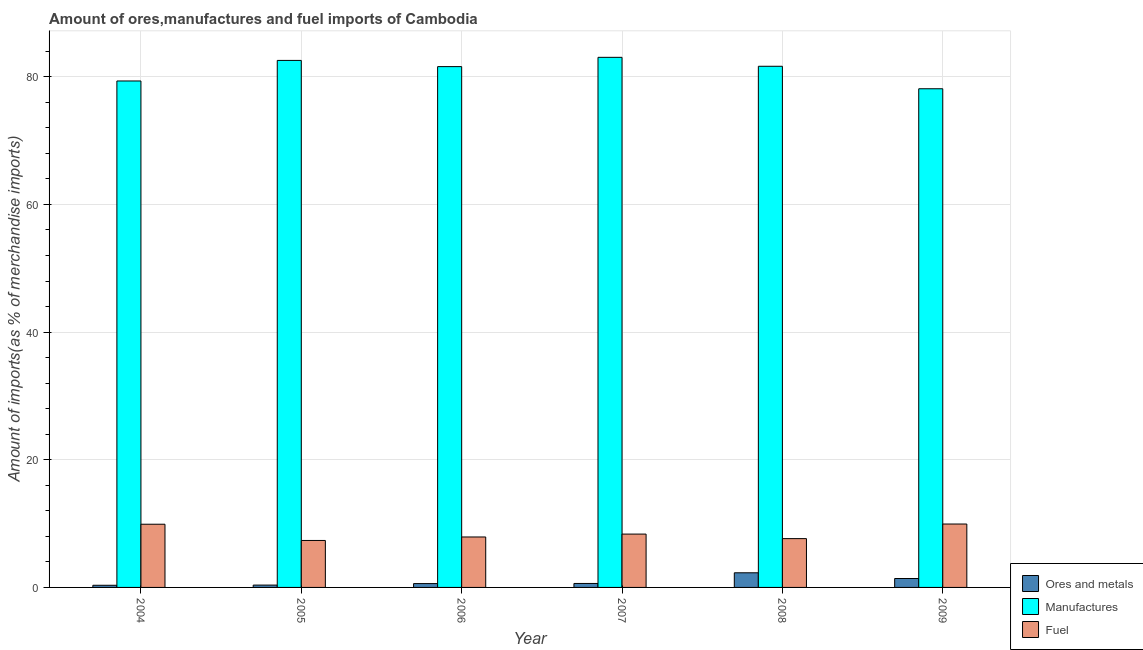How many different coloured bars are there?
Offer a very short reply. 3. How many groups of bars are there?
Make the answer very short. 6. Are the number of bars on each tick of the X-axis equal?
Provide a short and direct response. Yes. How many bars are there on the 2nd tick from the left?
Provide a succinct answer. 3. What is the percentage of ores and metals imports in 2008?
Ensure brevity in your answer.  2.29. Across all years, what is the maximum percentage of manufactures imports?
Offer a terse response. 83.05. Across all years, what is the minimum percentage of ores and metals imports?
Make the answer very short. 0.34. In which year was the percentage of manufactures imports maximum?
Make the answer very short. 2007. In which year was the percentage of manufactures imports minimum?
Offer a very short reply. 2009. What is the total percentage of fuel imports in the graph?
Keep it short and to the point. 51.1. What is the difference between the percentage of manufactures imports in 2004 and that in 2005?
Keep it short and to the point. -3.22. What is the difference between the percentage of fuel imports in 2007 and the percentage of ores and metals imports in 2008?
Your answer should be compact. 0.71. What is the average percentage of fuel imports per year?
Give a very brief answer. 8.52. In the year 2004, what is the difference between the percentage of ores and metals imports and percentage of manufactures imports?
Provide a succinct answer. 0. What is the ratio of the percentage of manufactures imports in 2004 to that in 2009?
Provide a short and direct response. 1.02. Is the difference between the percentage of fuel imports in 2004 and 2008 greater than the difference between the percentage of ores and metals imports in 2004 and 2008?
Your response must be concise. No. What is the difference between the highest and the second highest percentage of fuel imports?
Provide a succinct answer. 0.03. What is the difference between the highest and the lowest percentage of ores and metals imports?
Your answer should be compact. 1.96. In how many years, is the percentage of manufactures imports greater than the average percentage of manufactures imports taken over all years?
Your answer should be compact. 4. What does the 1st bar from the left in 2004 represents?
Your answer should be very brief. Ores and metals. What does the 1st bar from the right in 2007 represents?
Give a very brief answer. Fuel. Is it the case that in every year, the sum of the percentage of ores and metals imports and percentage of manufactures imports is greater than the percentage of fuel imports?
Your response must be concise. Yes. Are all the bars in the graph horizontal?
Your response must be concise. No. Are the values on the major ticks of Y-axis written in scientific E-notation?
Your response must be concise. No. Does the graph contain any zero values?
Offer a very short reply. No. Does the graph contain grids?
Your answer should be compact. Yes. Where does the legend appear in the graph?
Offer a very short reply. Bottom right. How many legend labels are there?
Provide a short and direct response. 3. What is the title of the graph?
Provide a succinct answer. Amount of ores,manufactures and fuel imports of Cambodia. Does "Agriculture" appear as one of the legend labels in the graph?
Provide a succinct answer. No. What is the label or title of the Y-axis?
Keep it short and to the point. Amount of imports(as % of merchandise imports). What is the Amount of imports(as % of merchandise imports) in Ores and metals in 2004?
Offer a very short reply. 0.34. What is the Amount of imports(as % of merchandise imports) in Manufactures in 2004?
Keep it short and to the point. 79.35. What is the Amount of imports(as % of merchandise imports) of Fuel in 2004?
Keep it short and to the point. 9.9. What is the Amount of imports(as % of merchandise imports) of Ores and metals in 2005?
Keep it short and to the point. 0.37. What is the Amount of imports(as % of merchandise imports) of Manufactures in 2005?
Ensure brevity in your answer.  82.57. What is the Amount of imports(as % of merchandise imports) in Fuel in 2005?
Offer a very short reply. 7.36. What is the Amount of imports(as % of merchandise imports) of Ores and metals in 2006?
Offer a terse response. 0.6. What is the Amount of imports(as % of merchandise imports) in Manufactures in 2006?
Your response must be concise. 81.6. What is the Amount of imports(as % of merchandise imports) in Fuel in 2006?
Ensure brevity in your answer.  7.9. What is the Amount of imports(as % of merchandise imports) in Ores and metals in 2007?
Your answer should be very brief. 0.62. What is the Amount of imports(as % of merchandise imports) of Manufactures in 2007?
Provide a succinct answer. 83.05. What is the Amount of imports(as % of merchandise imports) of Fuel in 2007?
Provide a short and direct response. 8.36. What is the Amount of imports(as % of merchandise imports) in Ores and metals in 2008?
Your answer should be compact. 2.29. What is the Amount of imports(as % of merchandise imports) in Manufactures in 2008?
Provide a short and direct response. 81.65. What is the Amount of imports(as % of merchandise imports) in Fuel in 2008?
Keep it short and to the point. 7.65. What is the Amount of imports(as % of merchandise imports) of Ores and metals in 2009?
Keep it short and to the point. 1.4. What is the Amount of imports(as % of merchandise imports) of Manufactures in 2009?
Offer a very short reply. 78.13. What is the Amount of imports(as % of merchandise imports) of Fuel in 2009?
Offer a very short reply. 9.93. Across all years, what is the maximum Amount of imports(as % of merchandise imports) of Ores and metals?
Your answer should be very brief. 2.29. Across all years, what is the maximum Amount of imports(as % of merchandise imports) of Manufactures?
Your response must be concise. 83.05. Across all years, what is the maximum Amount of imports(as % of merchandise imports) of Fuel?
Keep it short and to the point. 9.93. Across all years, what is the minimum Amount of imports(as % of merchandise imports) in Ores and metals?
Offer a very short reply. 0.34. Across all years, what is the minimum Amount of imports(as % of merchandise imports) of Manufactures?
Your answer should be compact. 78.13. Across all years, what is the minimum Amount of imports(as % of merchandise imports) of Fuel?
Your answer should be very brief. 7.36. What is the total Amount of imports(as % of merchandise imports) of Ores and metals in the graph?
Give a very brief answer. 5.61. What is the total Amount of imports(as % of merchandise imports) of Manufactures in the graph?
Make the answer very short. 486.33. What is the total Amount of imports(as % of merchandise imports) in Fuel in the graph?
Give a very brief answer. 51.1. What is the difference between the Amount of imports(as % of merchandise imports) in Ores and metals in 2004 and that in 2005?
Your response must be concise. -0.03. What is the difference between the Amount of imports(as % of merchandise imports) of Manufactures in 2004 and that in 2005?
Give a very brief answer. -3.22. What is the difference between the Amount of imports(as % of merchandise imports) in Fuel in 2004 and that in 2005?
Offer a very short reply. 2.54. What is the difference between the Amount of imports(as % of merchandise imports) in Ores and metals in 2004 and that in 2006?
Ensure brevity in your answer.  -0.26. What is the difference between the Amount of imports(as % of merchandise imports) in Manufactures in 2004 and that in 2006?
Your response must be concise. -2.25. What is the difference between the Amount of imports(as % of merchandise imports) in Fuel in 2004 and that in 2006?
Offer a very short reply. 2. What is the difference between the Amount of imports(as % of merchandise imports) in Ores and metals in 2004 and that in 2007?
Your answer should be compact. -0.28. What is the difference between the Amount of imports(as % of merchandise imports) of Manufactures in 2004 and that in 2007?
Offer a terse response. -3.7. What is the difference between the Amount of imports(as % of merchandise imports) in Fuel in 2004 and that in 2007?
Offer a terse response. 1.54. What is the difference between the Amount of imports(as % of merchandise imports) in Ores and metals in 2004 and that in 2008?
Make the answer very short. -1.96. What is the difference between the Amount of imports(as % of merchandise imports) of Manufactures in 2004 and that in 2008?
Ensure brevity in your answer.  -2.3. What is the difference between the Amount of imports(as % of merchandise imports) of Fuel in 2004 and that in 2008?
Your answer should be very brief. 2.25. What is the difference between the Amount of imports(as % of merchandise imports) in Ores and metals in 2004 and that in 2009?
Provide a succinct answer. -1.06. What is the difference between the Amount of imports(as % of merchandise imports) of Manufactures in 2004 and that in 2009?
Offer a terse response. 1.22. What is the difference between the Amount of imports(as % of merchandise imports) in Fuel in 2004 and that in 2009?
Provide a short and direct response. -0.03. What is the difference between the Amount of imports(as % of merchandise imports) of Ores and metals in 2005 and that in 2006?
Give a very brief answer. -0.24. What is the difference between the Amount of imports(as % of merchandise imports) in Manufactures in 2005 and that in 2006?
Provide a short and direct response. 0.97. What is the difference between the Amount of imports(as % of merchandise imports) of Fuel in 2005 and that in 2006?
Your answer should be compact. -0.55. What is the difference between the Amount of imports(as % of merchandise imports) in Ores and metals in 2005 and that in 2007?
Ensure brevity in your answer.  -0.25. What is the difference between the Amount of imports(as % of merchandise imports) in Manufactures in 2005 and that in 2007?
Ensure brevity in your answer.  -0.48. What is the difference between the Amount of imports(as % of merchandise imports) in Fuel in 2005 and that in 2007?
Your answer should be compact. -1. What is the difference between the Amount of imports(as % of merchandise imports) of Ores and metals in 2005 and that in 2008?
Your answer should be compact. -1.93. What is the difference between the Amount of imports(as % of merchandise imports) of Manufactures in 2005 and that in 2008?
Keep it short and to the point. 0.92. What is the difference between the Amount of imports(as % of merchandise imports) in Fuel in 2005 and that in 2008?
Make the answer very short. -0.29. What is the difference between the Amount of imports(as % of merchandise imports) of Ores and metals in 2005 and that in 2009?
Your answer should be compact. -1.03. What is the difference between the Amount of imports(as % of merchandise imports) of Manufactures in 2005 and that in 2009?
Provide a succinct answer. 4.44. What is the difference between the Amount of imports(as % of merchandise imports) of Fuel in 2005 and that in 2009?
Give a very brief answer. -2.57. What is the difference between the Amount of imports(as % of merchandise imports) of Ores and metals in 2006 and that in 2007?
Offer a very short reply. -0.02. What is the difference between the Amount of imports(as % of merchandise imports) of Manufactures in 2006 and that in 2007?
Provide a succinct answer. -1.46. What is the difference between the Amount of imports(as % of merchandise imports) in Fuel in 2006 and that in 2007?
Make the answer very short. -0.45. What is the difference between the Amount of imports(as % of merchandise imports) of Ores and metals in 2006 and that in 2008?
Provide a short and direct response. -1.69. What is the difference between the Amount of imports(as % of merchandise imports) in Manufactures in 2006 and that in 2008?
Provide a succinct answer. -0.05. What is the difference between the Amount of imports(as % of merchandise imports) of Fuel in 2006 and that in 2008?
Provide a succinct answer. 0.26. What is the difference between the Amount of imports(as % of merchandise imports) of Ores and metals in 2006 and that in 2009?
Ensure brevity in your answer.  -0.8. What is the difference between the Amount of imports(as % of merchandise imports) of Manufactures in 2006 and that in 2009?
Offer a very short reply. 3.47. What is the difference between the Amount of imports(as % of merchandise imports) of Fuel in 2006 and that in 2009?
Keep it short and to the point. -2.03. What is the difference between the Amount of imports(as % of merchandise imports) of Ores and metals in 2007 and that in 2008?
Your answer should be very brief. -1.67. What is the difference between the Amount of imports(as % of merchandise imports) of Manufactures in 2007 and that in 2008?
Keep it short and to the point. 1.4. What is the difference between the Amount of imports(as % of merchandise imports) of Fuel in 2007 and that in 2008?
Your answer should be very brief. 0.71. What is the difference between the Amount of imports(as % of merchandise imports) in Ores and metals in 2007 and that in 2009?
Your response must be concise. -0.78. What is the difference between the Amount of imports(as % of merchandise imports) in Manufactures in 2007 and that in 2009?
Offer a very short reply. 4.92. What is the difference between the Amount of imports(as % of merchandise imports) of Fuel in 2007 and that in 2009?
Offer a terse response. -1.57. What is the difference between the Amount of imports(as % of merchandise imports) of Ores and metals in 2008 and that in 2009?
Give a very brief answer. 0.89. What is the difference between the Amount of imports(as % of merchandise imports) of Manufactures in 2008 and that in 2009?
Your response must be concise. 3.52. What is the difference between the Amount of imports(as % of merchandise imports) in Fuel in 2008 and that in 2009?
Make the answer very short. -2.29. What is the difference between the Amount of imports(as % of merchandise imports) of Ores and metals in 2004 and the Amount of imports(as % of merchandise imports) of Manufactures in 2005?
Your response must be concise. -82.23. What is the difference between the Amount of imports(as % of merchandise imports) in Ores and metals in 2004 and the Amount of imports(as % of merchandise imports) in Fuel in 2005?
Give a very brief answer. -7.02. What is the difference between the Amount of imports(as % of merchandise imports) of Manufactures in 2004 and the Amount of imports(as % of merchandise imports) of Fuel in 2005?
Offer a very short reply. 71.99. What is the difference between the Amount of imports(as % of merchandise imports) in Ores and metals in 2004 and the Amount of imports(as % of merchandise imports) in Manufactures in 2006?
Your response must be concise. -81.26. What is the difference between the Amount of imports(as % of merchandise imports) in Ores and metals in 2004 and the Amount of imports(as % of merchandise imports) in Fuel in 2006?
Your answer should be compact. -7.57. What is the difference between the Amount of imports(as % of merchandise imports) in Manufactures in 2004 and the Amount of imports(as % of merchandise imports) in Fuel in 2006?
Offer a very short reply. 71.44. What is the difference between the Amount of imports(as % of merchandise imports) of Ores and metals in 2004 and the Amount of imports(as % of merchandise imports) of Manufactures in 2007?
Give a very brief answer. -82.71. What is the difference between the Amount of imports(as % of merchandise imports) of Ores and metals in 2004 and the Amount of imports(as % of merchandise imports) of Fuel in 2007?
Make the answer very short. -8.02. What is the difference between the Amount of imports(as % of merchandise imports) in Manufactures in 2004 and the Amount of imports(as % of merchandise imports) in Fuel in 2007?
Provide a short and direct response. 70.99. What is the difference between the Amount of imports(as % of merchandise imports) of Ores and metals in 2004 and the Amount of imports(as % of merchandise imports) of Manufactures in 2008?
Provide a succinct answer. -81.31. What is the difference between the Amount of imports(as % of merchandise imports) of Ores and metals in 2004 and the Amount of imports(as % of merchandise imports) of Fuel in 2008?
Give a very brief answer. -7.31. What is the difference between the Amount of imports(as % of merchandise imports) in Manufactures in 2004 and the Amount of imports(as % of merchandise imports) in Fuel in 2008?
Ensure brevity in your answer.  71.7. What is the difference between the Amount of imports(as % of merchandise imports) in Ores and metals in 2004 and the Amount of imports(as % of merchandise imports) in Manufactures in 2009?
Keep it short and to the point. -77.79. What is the difference between the Amount of imports(as % of merchandise imports) in Ores and metals in 2004 and the Amount of imports(as % of merchandise imports) in Fuel in 2009?
Ensure brevity in your answer.  -9.6. What is the difference between the Amount of imports(as % of merchandise imports) in Manufactures in 2004 and the Amount of imports(as % of merchandise imports) in Fuel in 2009?
Give a very brief answer. 69.41. What is the difference between the Amount of imports(as % of merchandise imports) in Ores and metals in 2005 and the Amount of imports(as % of merchandise imports) in Manufactures in 2006?
Your response must be concise. -81.23. What is the difference between the Amount of imports(as % of merchandise imports) of Ores and metals in 2005 and the Amount of imports(as % of merchandise imports) of Fuel in 2006?
Give a very brief answer. -7.54. What is the difference between the Amount of imports(as % of merchandise imports) in Manufactures in 2005 and the Amount of imports(as % of merchandise imports) in Fuel in 2006?
Give a very brief answer. 74.66. What is the difference between the Amount of imports(as % of merchandise imports) in Ores and metals in 2005 and the Amount of imports(as % of merchandise imports) in Manufactures in 2007?
Provide a succinct answer. -82.68. What is the difference between the Amount of imports(as % of merchandise imports) of Ores and metals in 2005 and the Amount of imports(as % of merchandise imports) of Fuel in 2007?
Provide a succinct answer. -7.99. What is the difference between the Amount of imports(as % of merchandise imports) of Manufactures in 2005 and the Amount of imports(as % of merchandise imports) of Fuel in 2007?
Your answer should be compact. 74.21. What is the difference between the Amount of imports(as % of merchandise imports) of Ores and metals in 2005 and the Amount of imports(as % of merchandise imports) of Manufactures in 2008?
Your response must be concise. -81.28. What is the difference between the Amount of imports(as % of merchandise imports) in Ores and metals in 2005 and the Amount of imports(as % of merchandise imports) in Fuel in 2008?
Provide a short and direct response. -7.28. What is the difference between the Amount of imports(as % of merchandise imports) in Manufactures in 2005 and the Amount of imports(as % of merchandise imports) in Fuel in 2008?
Offer a very short reply. 74.92. What is the difference between the Amount of imports(as % of merchandise imports) in Ores and metals in 2005 and the Amount of imports(as % of merchandise imports) in Manufactures in 2009?
Ensure brevity in your answer.  -77.76. What is the difference between the Amount of imports(as % of merchandise imports) of Ores and metals in 2005 and the Amount of imports(as % of merchandise imports) of Fuel in 2009?
Make the answer very short. -9.57. What is the difference between the Amount of imports(as % of merchandise imports) of Manufactures in 2005 and the Amount of imports(as % of merchandise imports) of Fuel in 2009?
Your answer should be compact. 72.63. What is the difference between the Amount of imports(as % of merchandise imports) in Ores and metals in 2006 and the Amount of imports(as % of merchandise imports) in Manufactures in 2007?
Make the answer very short. -82.45. What is the difference between the Amount of imports(as % of merchandise imports) in Ores and metals in 2006 and the Amount of imports(as % of merchandise imports) in Fuel in 2007?
Give a very brief answer. -7.76. What is the difference between the Amount of imports(as % of merchandise imports) in Manufactures in 2006 and the Amount of imports(as % of merchandise imports) in Fuel in 2007?
Your response must be concise. 73.24. What is the difference between the Amount of imports(as % of merchandise imports) in Ores and metals in 2006 and the Amount of imports(as % of merchandise imports) in Manufactures in 2008?
Provide a succinct answer. -81.05. What is the difference between the Amount of imports(as % of merchandise imports) in Ores and metals in 2006 and the Amount of imports(as % of merchandise imports) in Fuel in 2008?
Your answer should be compact. -7.05. What is the difference between the Amount of imports(as % of merchandise imports) of Manufactures in 2006 and the Amount of imports(as % of merchandise imports) of Fuel in 2008?
Provide a succinct answer. 73.95. What is the difference between the Amount of imports(as % of merchandise imports) in Ores and metals in 2006 and the Amount of imports(as % of merchandise imports) in Manufactures in 2009?
Ensure brevity in your answer.  -77.52. What is the difference between the Amount of imports(as % of merchandise imports) in Ores and metals in 2006 and the Amount of imports(as % of merchandise imports) in Fuel in 2009?
Provide a short and direct response. -9.33. What is the difference between the Amount of imports(as % of merchandise imports) in Manufactures in 2006 and the Amount of imports(as % of merchandise imports) in Fuel in 2009?
Provide a succinct answer. 71.66. What is the difference between the Amount of imports(as % of merchandise imports) in Ores and metals in 2007 and the Amount of imports(as % of merchandise imports) in Manufactures in 2008?
Provide a short and direct response. -81.03. What is the difference between the Amount of imports(as % of merchandise imports) of Ores and metals in 2007 and the Amount of imports(as % of merchandise imports) of Fuel in 2008?
Your answer should be compact. -7.03. What is the difference between the Amount of imports(as % of merchandise imports) of Manufactures in 2007 and the Amount of imports(as % of merchandise imports) of Fuel in 2008?
Provide a short and direct response. 75.4. What is the difference between the Amount of imports(as % of merchandise imports) in Ores and metals in 2007 and the Amount of imports(as % of merchandise imports) in Manufactures in 2009?
Make the answer very short. -77.51. What is the difference between the Amount of imports(as % of merchandise imports) in Ores and metals in 2007 and the Amount of imports(as % of merchandise imports) in Fuel in 2009?
Your answer should be very brief. -9.31. What is the difference between the Amount of imports(as % of merchandise imports) of Manufactures in 2007 and the Amount of imports(as % of merchandise imports) of Fuel in 2009?
Offer a very short reply. 73.12. What is the difference between the Amount of imports(as % of merchandise imports) of Ores and metals in 2008 and the Amount of imports(as % of merchandise imports) of Manufactures in 2009?
Provide a succinct answer. -75.83. What is the difference between the Amount of imports(as % of merchandise imports) of Ores and metals in 2008 and the Amount of imports(as % of merchandise imports) of Fuel in 2009?
Your answer should be very brief. -7.64. What is the difference between the Amount of imports(as % of merchandise imports) in Manufactures in 2008 and the Amount of imports(as % of merchandise imports) in Fuel in 2009?
Give a very brief answer. 71.72. What is the average Amount of imports(as % of merchandise imports) in Ores and metals per year?
Offer a terse response. 0.94. What is the average Amount of imports(as % of merchandise imports) in Manufactures per year?
Your response must be concise. 81.06. What is the average Amount of imports(as % of merchandise imports) of Fuel per year?
Offer a terse response. 8.52. In the year 2004, what is the difference between the Amount of imports(as % of merchandise imports) of Ores and metals and Amount of imports(as % of merchandise imports) of Manufactures?
Make the answer very short. -79.01. In the year 2004, what is the difference between the Amount of imports(as % of merchandise imports) of Ores and metals and Amount of imports(as % of merchandise imports) of Fuel?
Offer a terse response. -9.56. In the year 2004, what is the difference between the Amount of imports(as % of merchandise imports) of Manufactures and Amount of imports(as % of merchandise imports) of Fuel?
Give a very brief answer. 69.45. In the year 2005, what is the difference between the Amount of imports(as % of merchandise imports) of Ores and metals and Amount of imports(as % of merchandise imports) of Manufactures?
Offer a very short reply. -82.2. In the year 2005, what is the difference between the Amount of imports(as % of merchandise imports) of Ores and metals and Amount of imports(as % of merchandise imports) of Fuel?
Keep it short and to the point. -6.99. In the year 2005, what is the difference between the Amount of imports(as % of merchandise imports) in Manufactures and Amount of imports(as % of merchandise imports) in Fuel?
Your response must be concise. 75.21. In the year 2006, what is the difference between the Amount of imports(as % of merchandise imports) of Ores and metals and Amount of imports(as % of merchandise imports) of Manufactures?
Ensure brevity in your answer.  -80.99. In the year 2006, what is the difference between the Amount of imports(as % of merchandise imports) in Ores and metals and Amount of imports(as % of merchandise imports) in Fuel?
Offer a terse response. -7.3. In the year 2006, what is the difference between the Amount of imports(as % of merchandise imports) of Manufactures and Amount of imports(as % of merchandise imports) of Fuel?
Ensure brevity in your answer.  73.69. In the year 2007, what is the difference between the Amount of imports(as % of merchandise imports) of Ores and metals and Amount of imports(as % of merchandise imports) of Manufactures?
Your answer should be very brief. -82.43. In the year 2007, what is the difference between the Amount of imports(as % of merchandise imports) in Ores and metals and Amount of imports(as % of merchandise imports) in Fuel?
Ensure brevity in your answer.  -7.74. In the year 2007, what is the difference between the Amount of imports(as % of merchandise imports) of Manufactures and Amount of imports(as % of merchandise imports) of Fuel?
Make the answer very short. 74.69. In the year 2008, what is the difference between the Amount of imports(as % of merchandise imports) of Ores and metals and Amount of imports(as % of merchandise imports) of Manufactures?
Give a very brief answer. -79.36. In the year 2008, what is the difference between the Amount of imports(as % of merchandise imports) in Ores and metals and Amount of imports(as % of merchandise imports) in Fuel?
Ensure brevity in your answer.  -5.35. In the year 2008, what is the difference between the Amount of imports(as % of merchandise imports) in Manufactures and Amount of imports(as % of merchandise imports) in Fuel?
Your answer should be very brief. 74. In the year 2009, what is the difference between the Amount of imports(as % of merchandise imports) of Ores and metals and Amount of imports(as % of merchandise imports) of Manufactures?
Make the answer very short. -76.73. In the year 2009, what is the difference between the Amount of imports(as % of merchandise imports) in Ores and metals and Amount of imports(as % of merchandise imports) in Fuel?
Give a very brief answer. -8.53. In the year 2009, what is the difference between the Amount of imports(as % of merchandise imports) of Manufactures and Amount of imports(as % of merchandise imports) of Fuel?
Offer a terse response. 68.19. What is the ratio of the Amount of imports(as % of merchandise imports) of Ores and metals in 2004 to that in 2005?
Your response must be concise. 0.92. What is the ratio of the Amount of imports(as % of merchandise imports) in Fuel in 2004 to that in 2005?
Make the answer very short. 1.35. What is the ratio of the Amount of imports(as % of merchandise imports) in Ores and metals in 2004 to that in 2006?
Offer a very short reply. 0.56. What is the ratio of the Amount of imports(as % of merchandise imports) in Manufactures in 2004 to that in 2006?
Provide a succinct answer. 0.97. What is the ratio of the Amount of imports(as % of merchandise imports) in Fuel in 2004 to that in 2006?
Offer a very short reply. 1.25. What is the ratio of the Amount of imports(as % of merchandise imports) in Ores and metals in 2004 to that in 2007?
Keep it short and to the point. 0.54. What is the ratio of the Amount of imports(as % of merchandise imports) of Manufactures in 2004 to that in 2007?
Your answer should be very brief. 0.96. What is the ratio of the Amount of imports(as % of merchandise imports) in Fuel in 2004 to that in 2007?
Ensure brevity in your answer.  1.18. What is the ratio of the Amount of imports(as % of merchandise imports) of Ores and metals in 2004 to that in 2008?
Give a very brief answer. 0.15. What is the ratio of the Amount of imports(as % of merchandise imports) in Manufactures in 2004 to that in 2008?
Provide a short and direct response. 0.97. What is the ratio of the Amount of imports(as % of merchandise imports) of Fuel in 2004 to that in 2008?
Give a very brief answer. 1.29. What is the ratio of the Amount of imports(as % of merchandise imports) in Ores and metals in 2004 to that in 2009?
Your answer should be very brief. 0.24. What is the ratio of the Amount of imports(as % of merchandise imports) of Manufactures in 2004 to that in 2009?
Ensure brevity in your answer.  1.02. What is the ratio of the Amount of imports(as % of merchandise imports) in Fuel in 2004 to that in 2009?
Offer a terse response. 1. What is the ratio of the Amount of imports(as % of merchandise imports) of Ores and metals in 2005 to that in 2006?
Offer a very short reply. 0.61. What is the ratio of the Amount of imports(as % of merchandise imports) of Manufactures in 2005 to that in 2006?
Provide a short and direct response. 1.01. What is the ratio of the Amount of imports(as % of merchandise imports) in Ores and metals in 2005 to that in 2007?
Your answer should be very brief. 0.59. What is the ratio of the Amount of imports(as % of merchandise imports) in Manufactures in 2005 to that in 2007?
Your response must be concise. 0.99. What is the ratio of the Amount of imports(as % of merchandise imports) of Fuel in 2005 to that in 2007?
Your answer should be very brief. 0.88. What is the ratio of the Amount of imports(as % of merchandise imports) of Ores and metals in 2005 to that in 2008?
Provide a succinct answer. 0.16. What is the ratio of the Amount of imports(as % of merchandise imports) of Manufactures in 2005 to that in 2008?
Give a very brief answer. 1.01. What is the ratio of the Amount of imports(as % of merchandise imports) of Fuel in 2005 to that in 2008?
Provide a short and direct response. 0.96. What is the ratio of the Amount of imports(as % of merchandise imports) in Ores and metals in 2005 to that in 2009?
Your answer should be compact. 0.26. What is the ratio of the Amount of imports(as % of merchandise imports) of Manufactures in 2005 to that in 2009?
Provide a short and direct response. 1.06. What is the ratio of the Amount of imports(as % of merchandise imports) in Fuel in 2005 to that in 2009?
Ensure brevity in your answer.  0.74. What is the ratio of the Amount of imports(as % of merchandise imports) in Ores and metals in 2006 to that in 2007?
Keep it short and to the point. 0.97. What is the ratio of the Amount of imports(as % of merchandise imports) in Manufactures in 2006 to that in 2007?
Ensure brevity in your answer.  0.98. What is the ratio of the Amount of imports(as % of merchandise imports) of Fuel in 2006 to that in 2007?
Your response must be concise. 0.95. What is the ratio of the Amount of imports(as % of merchandise imports) in Ores and metals in 2006 to that in 2008?
Provide a succinct answer. 0.26. What is the ratio of the Amount of imports(as % of merchandise imports) of Fuel in 2006 to that in 2008?
Give a very brief answer. 1.03. What is the ratio of the Amount of imports(as % of merchandise imports) in Ores and metals in 2006 to that in 2009?
Offer a very short reply. 0.43. What is the ratio of the Amount of imports(as % of merchandise imports) of Manufactures in 2006 to that in 2009?
Your answer should be compact. 1.04. What is the ratio of the Amount of imports(as % of merchandise imports) in Fuel in 2006 to that in 2009?
Make the answer very short. 0.8. What is the ratio of the Amount of imports(as % of merchandise imports) in Ores and metals in 2007 to that in 2008?
Ensure brevity in your answer.  0.27. What is the ratio of the Amount of imports(as % of merchandise imports) of Manufactures in 2007 to that in 2008?
Offer a very short reply. 1.02. What is the ratio of the Amount of imports(as % of merchandise imports) of Fuel in 2007 to that in 2008?
Your answer should be compact. 1.09. What is the ratio of the Amount of imports(as % of merchandise imports) of Ores and metals in 2007 to that in 2009?
Keep it short and to the point. 0.44. What is the ratio of the Amount of imports(as % of merchandise imports) in Manufactures in 2007 to that in 2009?
Keep it short and to the point. 1.06. What is the ratio of the Amount of imports(as % of merchandise imports) of Fuel in 2007 to that in 2009?
Your response must be concise. 0.84. What is the ratio of the Amount of imports(as % of merchandise imports) in Ores and metals in 2008 to that in 2009?
Make the answer very short. 1.64. What is the ratio of the Amount of imports(as % of merchandise imports) in Manufactures in 2008 to that in 2009?
Your answer should be compact. 1.05. What is the ratio of the Amount of imports(as % of merchandise imports) of Fuel in 2008 to that in 2009?
Keep it short and to the point. 0.77. What is the difference between the highest and the second highest Amount of imports(as % of merchandise imports) of Ores and metals?
Your answer should be compact. 0.89. What is the difference between the highest and the second highest Amount of imports(as % of merchandise imports) of Manufactures?
Keep it short and to the point. 0.48. What is the difference between the highest and the second highest Amount of imports(as % of merchandise imports) in Fuel?
Make the answer very short. 0.03. What is the difference between the highest and the lowest Amount of imports(as % of merchandise imports) in Ores and metals?
Make the answer very short. 1.96. What is the difference between the highest and the lowest Amount of imports(as % of merchandise imports) of Manufactures?
Your response must be concise. 4.92. What is the difference between the highest and the lowest Amount of imports(as % of merchandise imports) of Fuel?
Provide a short and direct response. 2.57. 